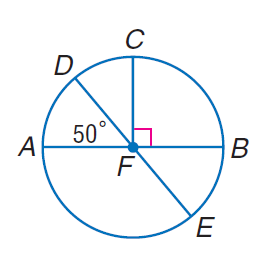Question: In \odot F, m \angle D F A = 50 and C F \perp F B. Find m \widehat C B E.
Choices:
A. 40
B. 45
C. 90
D. 140
Answer with the letter. Answer: D 